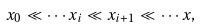Convert formula to latex. <formula><loc_0><loc_0><loc_500><loc_500>x _ { 0 } \ll \cdots x _ { i } \ll x _ { i + 1 } \ll \cdots x ,</formula> 